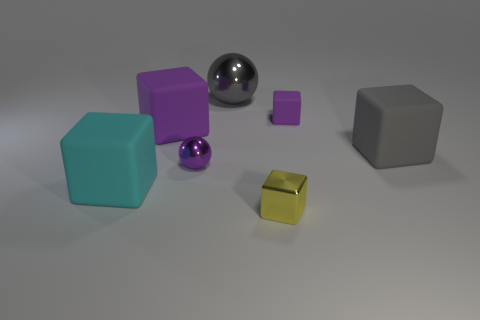What is the shape of the small object to the right of the yellow metal block?
Provide a succinct answer. Cube. There is another big object that is the same color as the big shiny object; what is its material?
Give a very brief answer. Rubber. What is the color of the metallic thing that is in front of the big cyan matte cube behind the yellow cube?
Your response must be concise. Yellow. Do the gray metallic thing and the yellow cube have the same size?
Your answer should be very brief. No. What is the material of the other tiny thing that is the same shape as the gray metallic thing?
Give a very brief answer. Metal. How many gray objects have the same size as the cyan block?
Ensure brevity in your answer.  2. The tiny block that is the same material as the large gray cube is what color?
Your response must be concise. Purple. Is the number of small rubber cubes less than the number of purple blocks?
Keep it short and to the point. Yes. What number of brown objects are tiny things or big spheres?
Offer a terse response. 0. How many big objects are in front of the big gray metal object and to the left of the big gray block?
Make the answer very short. 2. 